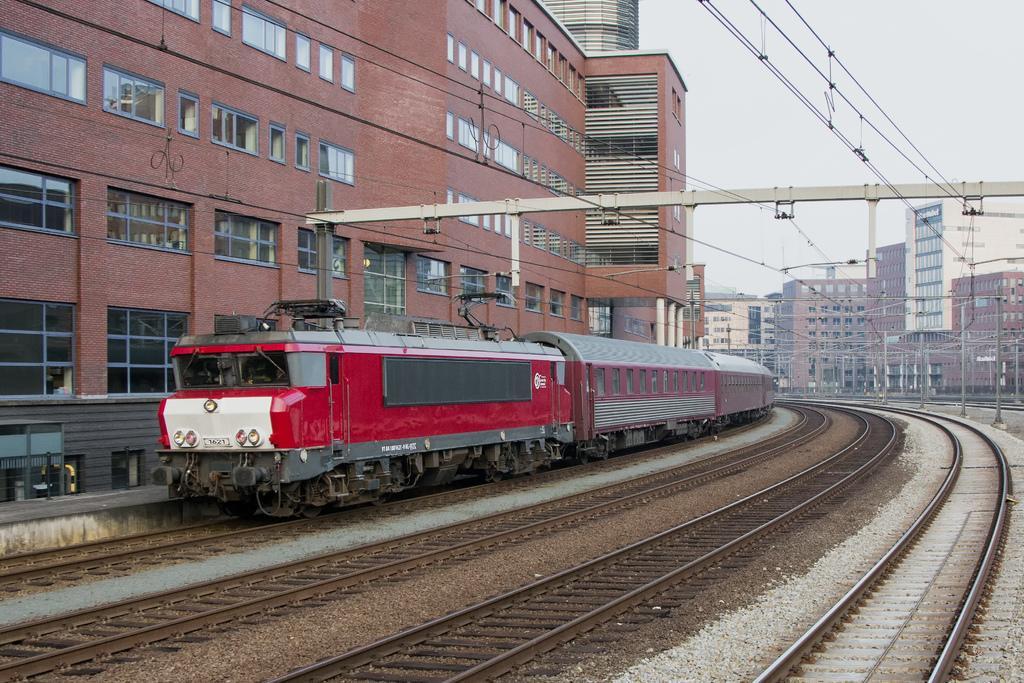Please provide a concise description of this image. In this image, we can see tracks and there is a train. In the background, there are buildings and we can see poles along with wires. At the top, there is sky. 